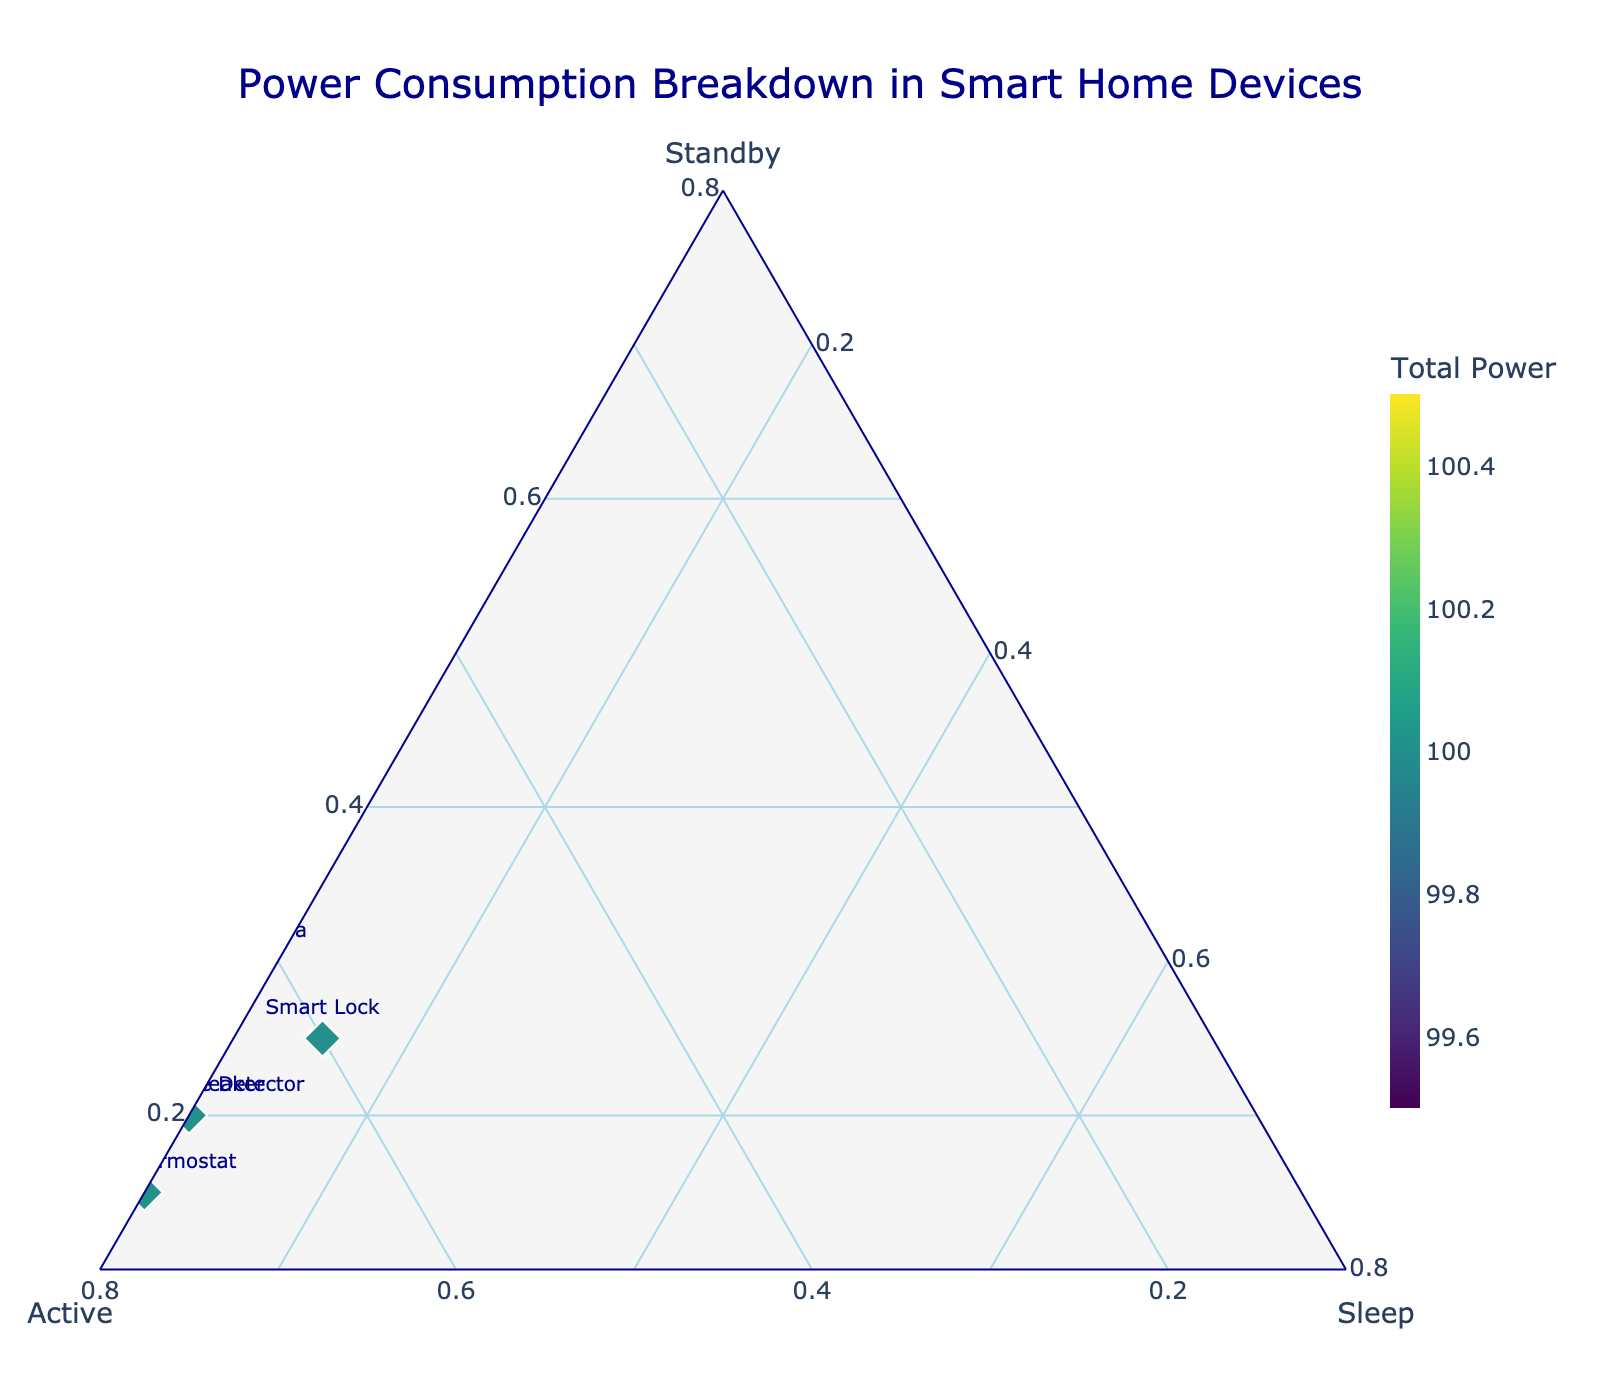What is the title of the figure? The title is typically located at the top of the figure and provides a brief summary of what the figure illustrates.
Answer: Power Consumption Breakdown in Smart Home Devices How many devices are represented in the figure? To find the number of devices represented, count the number of data points or labels marked on the graph.
Answer: 10 Which device has the highest active mode power consumption percentage? Identify the device positioned closest to the "Active" axis, which indicates maximum active mode power consumption.
Answer: Smart LED Bulb What is the total power consumption for Smart Refrigerator? Locate the Smart Refrigerator in the plot, identify the total power consumption from the color bar associated with the device.
Answer: 100 Which device has the lowest standby mode power consumption percentage? Find the device that is placed furthest from the "Standby" axis, indicating minimal standby power consumption.
Answer: Smart LED Bulb Compare the standby and active mode percentages for the Smart Lock. Observe the positions relative to the "Standby" and "Active" axes for Smart Lock. Record the percentages for both.
Answer: Standby: 25%, Active: 60% Arrange devices by total power consumption from highest to lowest. Locate each device's total power consumption using the color bar, then sort them accordingly.
Answer: Smart Refrigerator, Smart Doorbell, Smart TV, Smart Security Camera, Smart Lock, Smart Speaker, Smart Smoke Detector, Smart Thermostat, Smart LED Bulb, Smart Plug Which device has the highest sleep mode power consumption percentage? Identify the device positioned closest to the "Sleep" axis, indicating maximum sleep mode power consumption.
Answer: Smart Lock If the device with the median total power consumption is identified, which one is it? Arrange all devices by total power consumption and pick the one in the middle of this ordered list.
Answer: Smart Lock Calculate the average total power consumption of all devices. Sum the total power consumptions of all devices and divide by the number of devices. \( (100 + 95 + 100 + 100 + 100 + 100 + 100 + 95 + 100 + 100) / 10 = 990/10 \)
Answer: 99 